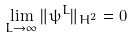Convert formula to latex. <formula><loc_0><loc_0><loc_500><loc_500>\lim _ { L \rightarrow \infty } \| \psi ^ { L } \| _ { H ^ { 2 } } = 0</formula> 